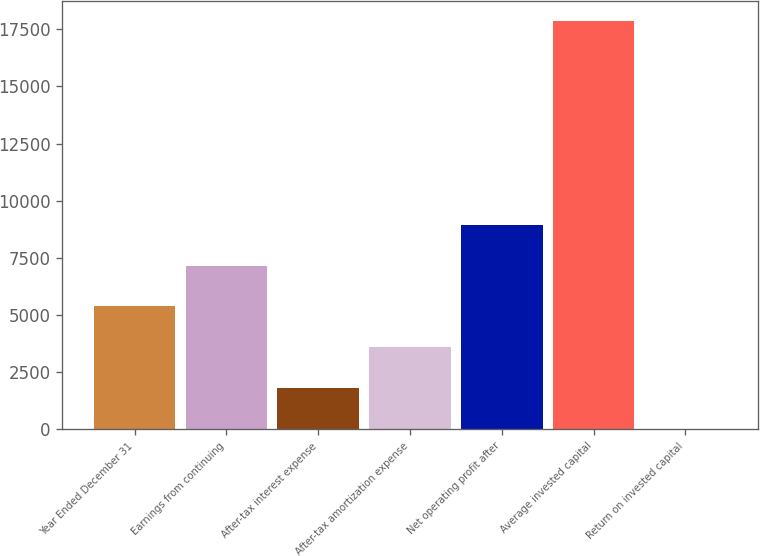<chart> <loc_0><loc_0><loc_500><loc_500><bar_chart><fcel>Year Ended December 31<fcel>Earnings from continuing<fcel>After-tax interest expense<fcel>After-tax amortization expense<fcel>Net operating profit after<fcel>Average invested capital<fcel>Return on invested capital<nl><fcel>5369.58<fcel>7153.64<fcel>1801.46<fcel>3585.52<fcel>8937.7<fcel>17858<fcel>17.4<nl></chart> 